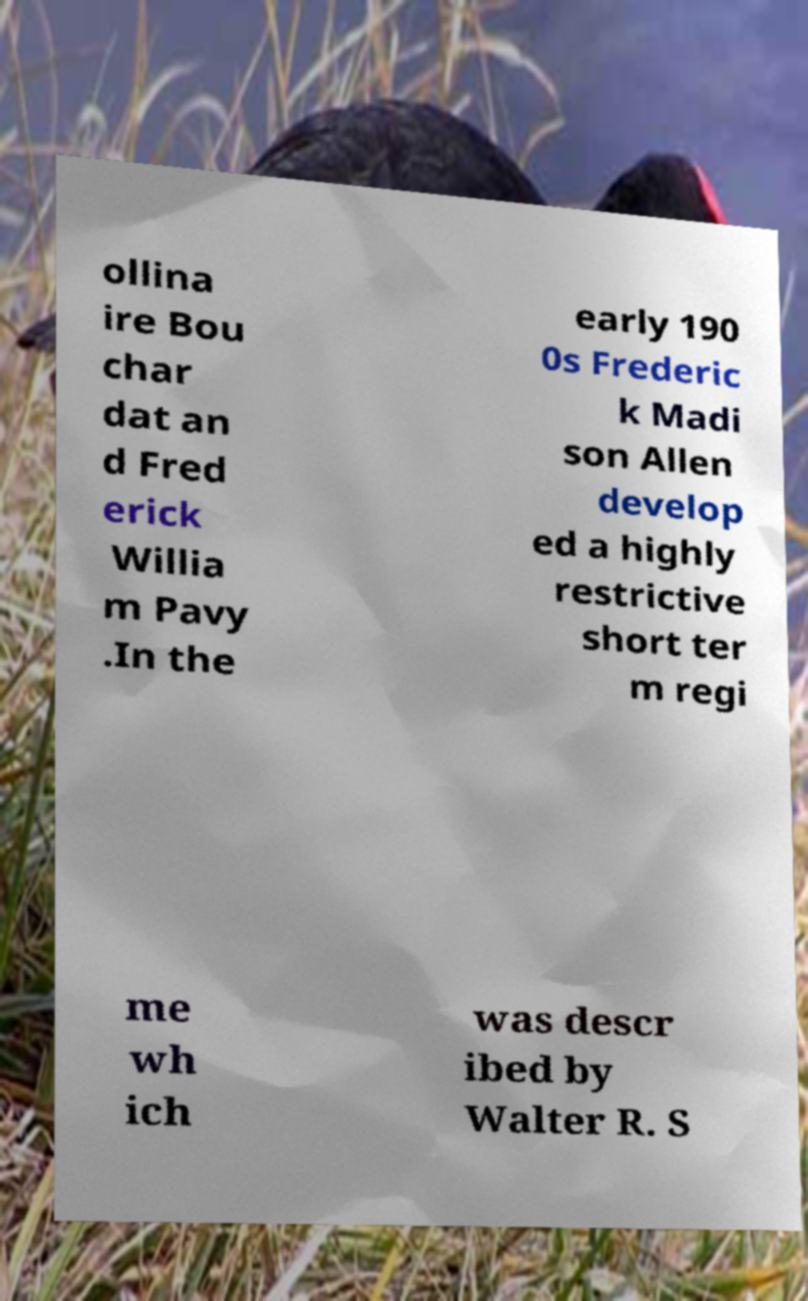Can you accurately transcribe the text from the provided image for me? ollina ire Bou char dat an d Fred erick Willia m Pavy .In the early 190 0s Frederic k Madi son Allen develop ed a highly restrictive short ter m regi me wh ich was descr ibed by Walter R. S 